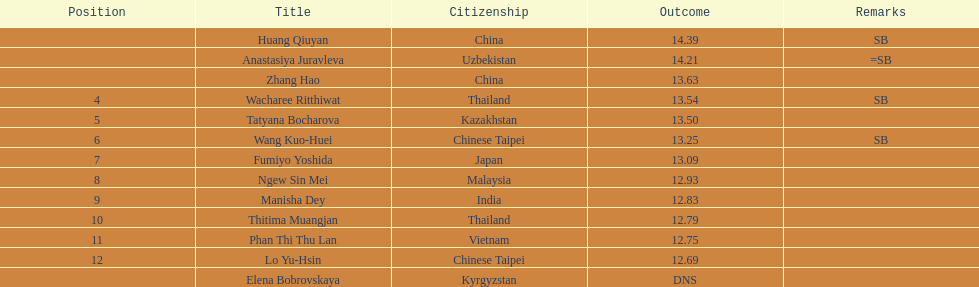How many competitors had less than 13.00 points? 6. 